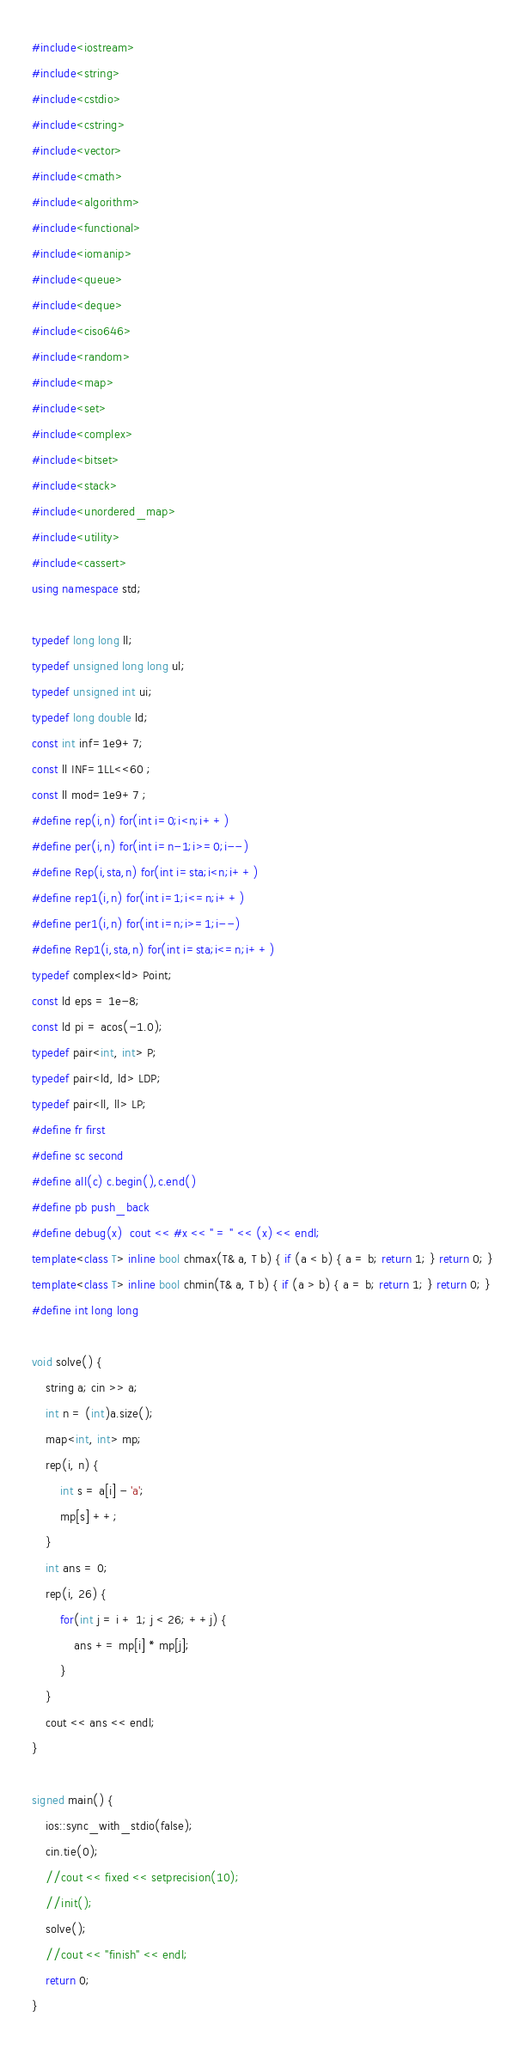<code> <loc_0><loc_0><loc_500><loc_500><_C++_>#include<iostream>
#include<string>
#include<cstdio>
#include<cstring>
#include<vector>
#include<cmath>
#include<algorithm>
#include<functional>
#include<iomanip>
#include<queue>
#include<deque>
#include<ciso646>
#include<random>
#include<map>
#include<set>
#include<complex>
#include<bitset>
#include<stack>
#include<unordered_map>
#include<utility>
#include<cassert>
using namespace std;

typedef long long ll;
typedef unsigned long long ul;
typedef unsigned int ui;
typedef long double ld;
const int inf=1e9+7;
const ll INF=1LL<<60 ;
const ll mod=1e9+7 ;
#define rep(i,n) for(int i=0;i<n;i++)
#define per(i,n) for(int i=n-1;i>=0;i--)
#define Rep(i,sta,n) for(int i=sta;i<n;i++)
#define rep1(i,n) for(int i=1;i<=n;i++)
#define per1(i,n) for(int i=n;i>=1;i--)
#define Rep1(i,sta,n) for(int i=sta;i<=n;i++)
typedef complex<ld> Point;
const ld eps = 1e-8;
const ld pi = acos(-1.0);
typedef pair<int, int> P;
typedef pair<ld, ld> LDP;
typedef pair<ll, ll> LP;
#define fr first
#define sc second
#define all(c) c.begin(),c.end()
#define pb push_back
#define debug(x)  cout << #x << " = " << (x) << endl;
template<class T> inline bool chmax(T& a, T b) { if (a < b) { a = b; return 1; } return 0; }
template<class T> inline bool chmin(T& a, T b) { if (a > b) { a = b; return 1; } return 0; }
#define int long long

void solve() {
	string a; cin >> a;
    int n = (int)a.size();
    map<int, int> mp;
    rep(i, n) {
        int s = a[i] - 'a';
        mp[s] ++;
    }
    int ans = 0;
    rep(i, 26) {
        for(int j = i + 1; j < 26; ++j) {
            ans += mp[i] * mp[j];
        }
    }
    cout << ans << endl;
}

signed main() {
	ios::sync_with_stdio(false);
	cin.tie(0);
	//cout << fixed << setprecision(10);
	//init();
	solve();
	//cout << "finish" << endl;
    return 0;
}</code> 